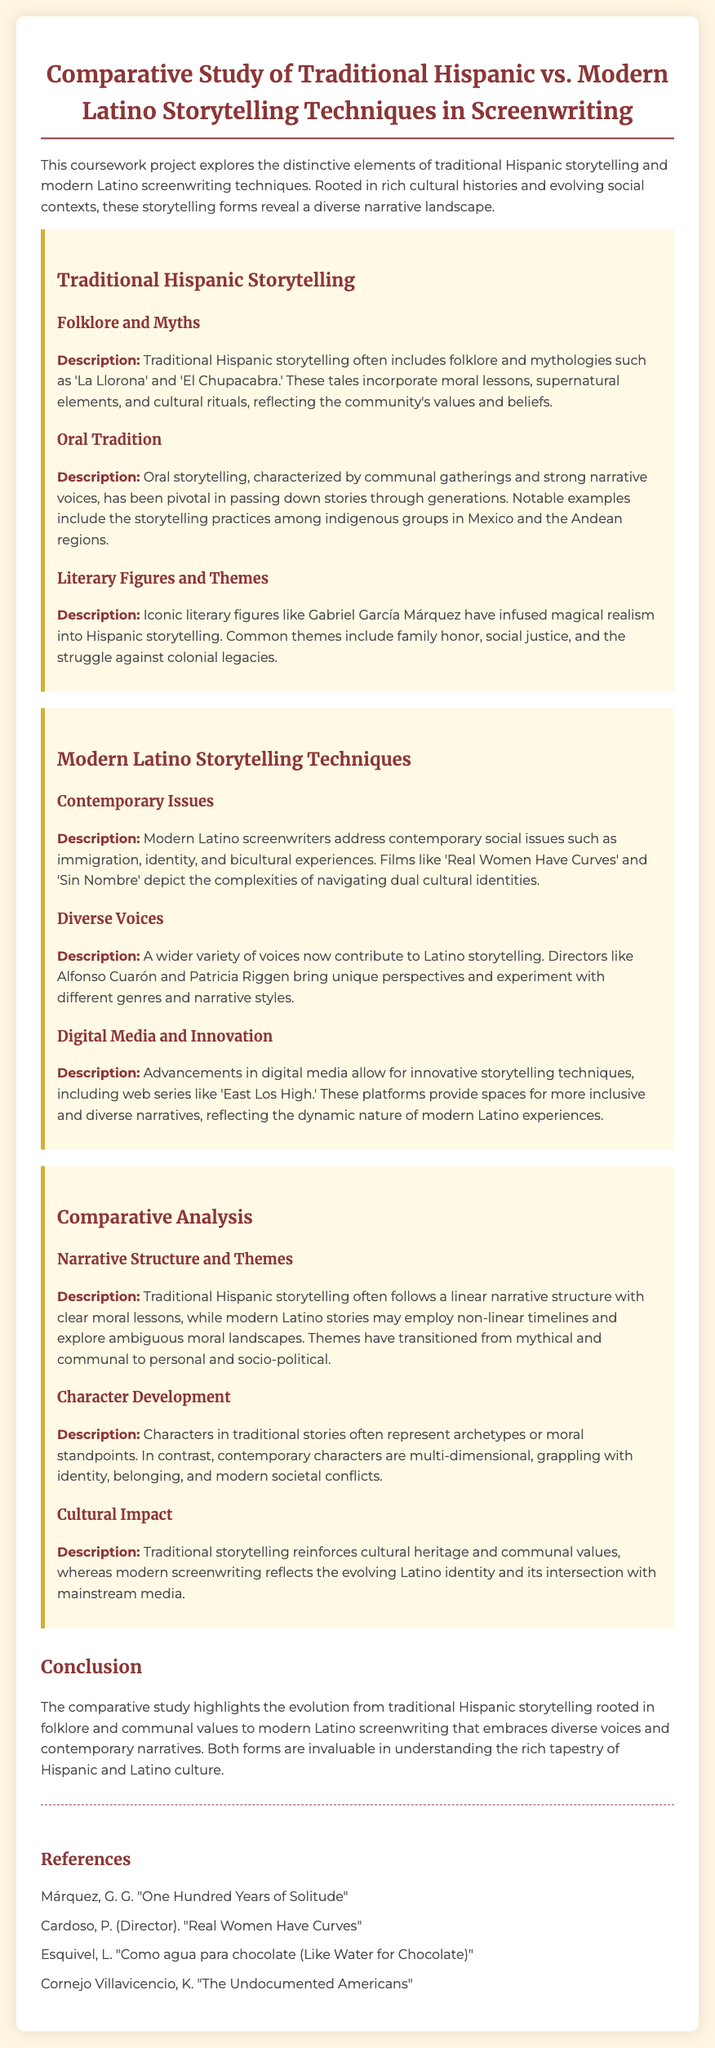What are two examples of folklore mentioned? The document specifies examples of folklore as 'La Llorona' and 'El Chupacabra.'
Answer: 'La Llorona' and 'El Chupacabra' Who is an iconic literary figure associated with magical realism? The document mentions Gabriel García Márquez as an iconic literary figure.
Answer: Gabriel García Márquez What contemporary issues do modern Latino screenwriters address? The document states that modern Latino screenwriters tackle issues such as immigration, identity, and bicultural experiences.
Answer: Immigration, identity, and bicultural experiences What type of media allows for innovative storytelling techniques? The document refers to advancements in digital media as a means for innovative storytelling techniques.
Answer: Digital media How does traditional Hispanic storytelling differ in structure from modern Latino stories? The document indicates that traditional Hispanic storytelling often follows a linear narrative structure, whereas modern Latino stories may use non-linear timelines.
Answer: Linear vs. non-linear What common themes were found in traditional Hispanic storytelling? The themes noted in traditional Hispanic storytelling include family honor, social justice, and the struggle against colonial legacies.
Answer: Family honor, social justice, and the struggle against colonial legacies Who directed the film 'Real Women Have Curves'? The document provides the name of the director, which is Patricia Cardoso.
Answer: Patricia Cardoso What does the comparative study highlight? The study emphasizes the evolution from traditional Hispanic storytelling to modern Latino screenwriting.
Answer: Evolution from traditional to modern storytelling 